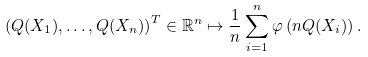<formula> <loc_0><loc_0><loc_500><loc_500>\left ( Q ( X _ { 1 } ) , \dots , Q ( X _ { n } ) \right ) ^ { T } \in \mathbb { R } ^ { n } \mapsto \frac { 1 } { n } \sum _ { i = 1 } ^ { n } \varphi \left ( n Q ( X _ { i } ) \right ) .</formula> 